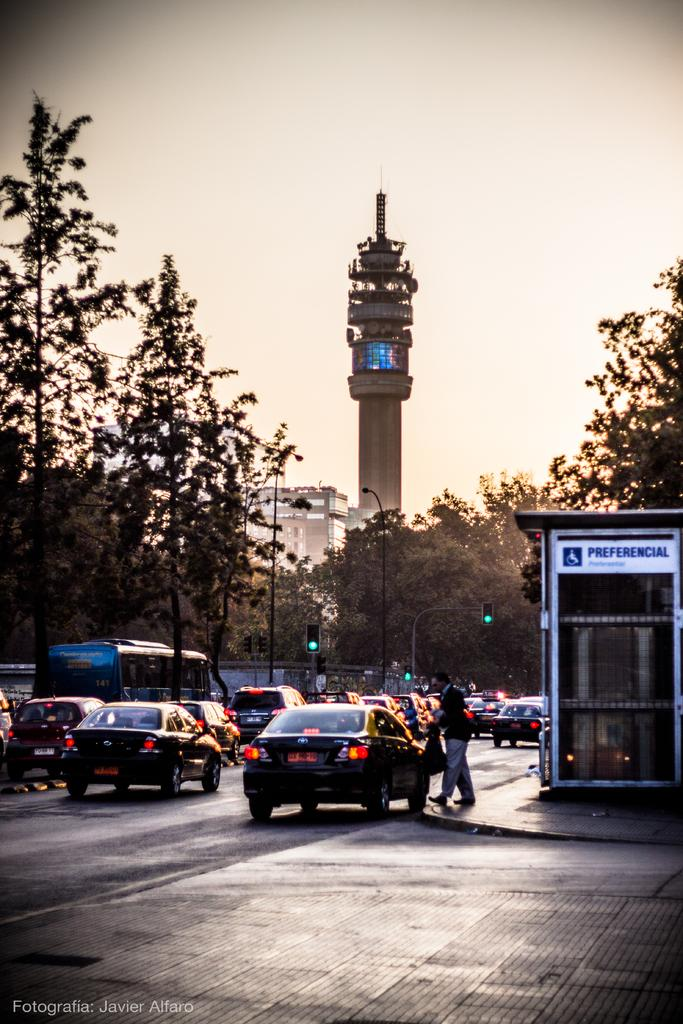What is happening on the road in the image? There are cars travelling on the road in the image. What type of vegetation can be seen in the image? There are trees visible in the image. What is used to regulate traffic in the image? There is a traffic signal in the image. What structure can be seen in the image besides the traffic signal? There is a pole and a tower in the image. What is visible in the background of the image? The sky is visible in the image. What advice is the apple giving to the ball in the image? There is no apple or ball present in the image, so no such interaction can be observed. 